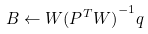Convert formula to latex. <formula><loc_0><loc_0><loc_500><loc_500>B \leftarrow W { ( P ^ { T } W ) } ^ { - 1 } q</formula> 